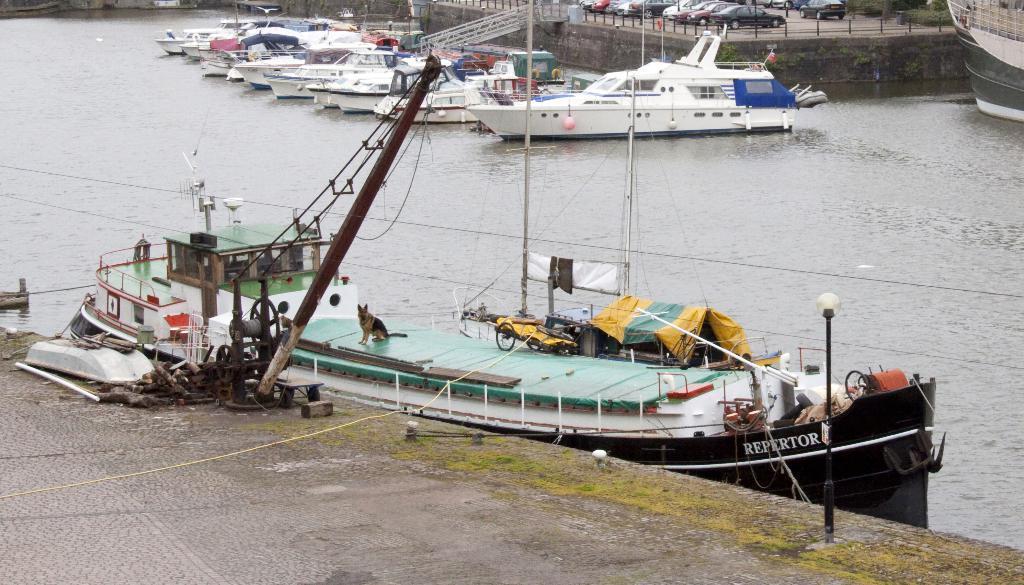In one or two sentences, can you explain what this image depicts? At the bottom of the image there is road. On the road there is a machine with pole and wheel. And also there are some other things on the floor. Behind that there is a ship on the water. On the ship there is a dog, railing and also there are poles, wires, ropes and other objects. And also there is a name on the ship. In the background there are few ships on the water. Behind the ships there is a wall with railings. Behind the railing there are vehicles. In the top right corner of the image there is a ship. 